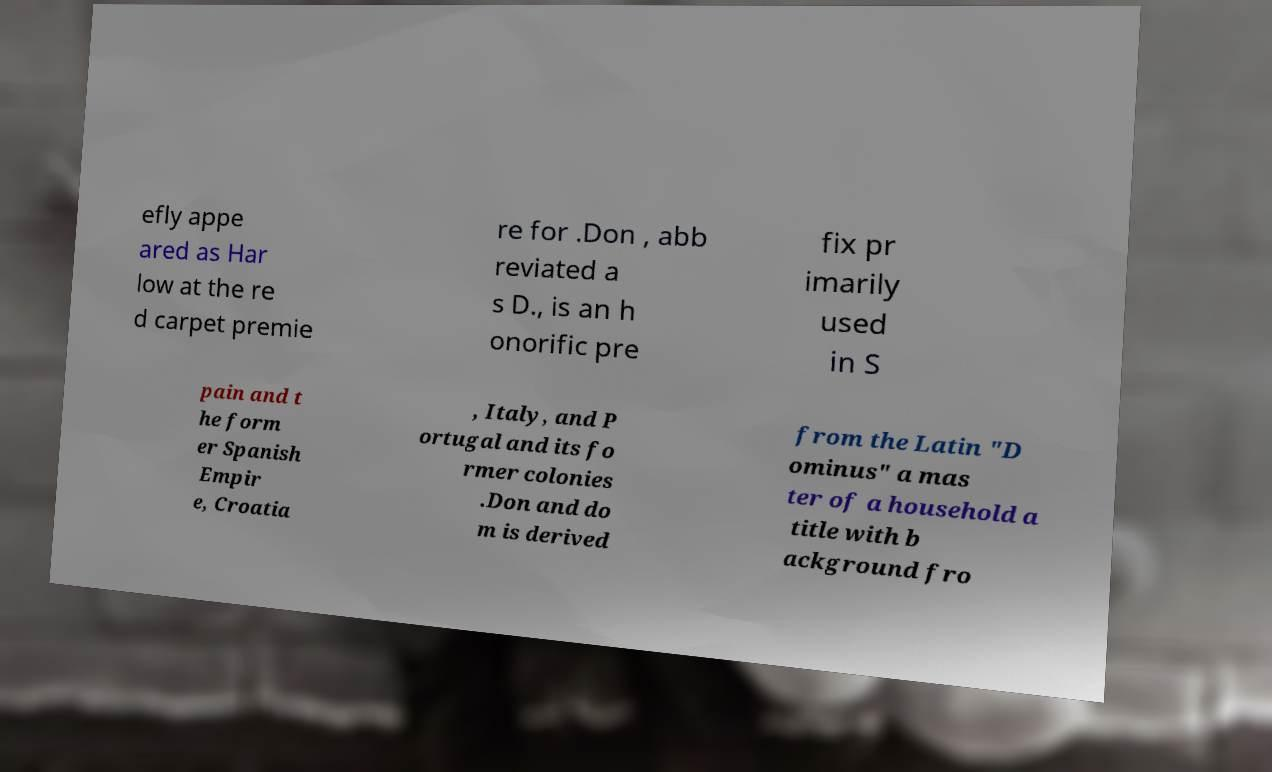Could you assist in decoding the text presented in this image and type it out clearly? efly appe ared as Har low at the re d carpet premie re for .Don , abb reviated a s D., is an h onorific pre fix pr imarily used in S pain and t he form er Spanish Empir e, Croatia , Italy, and P ortugal and its fo rmer colonies .Don and do m is derived from the Latin "D ominus" a mas ter of a household a title with b ackground fro 